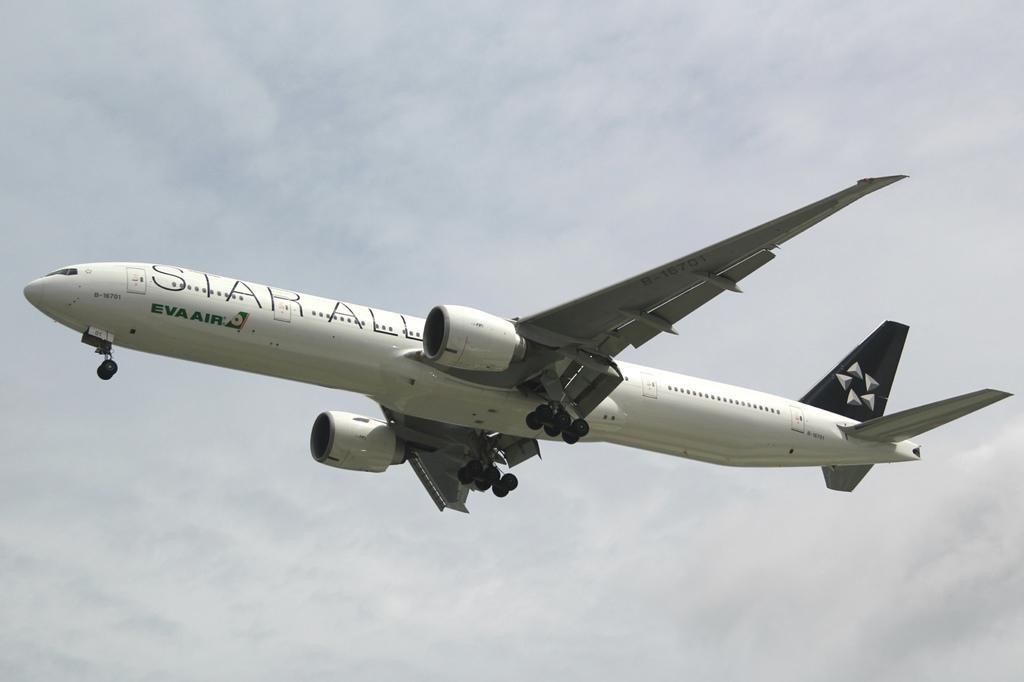In one or two sentences, can you explain what this image depicts? In this image, we can see an aeroplane in the air. Background there is a sky. 